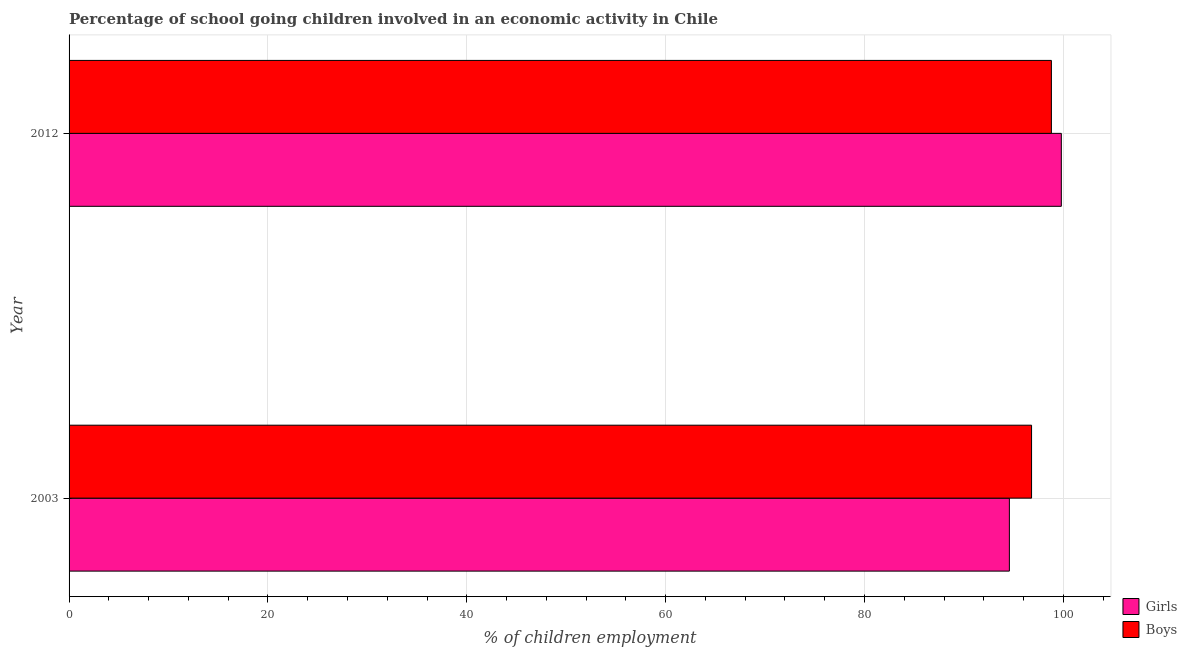Are the number of bars per tick equal to the number of legend labels?
Offer a very short reply. Yes. Are the number of bars on each tick of the Y-axis equal?
Provide a short and direct response. Yes. How many bars are there on the 2nd tick from the top?
Offer a terse response. 2. What is the percentage of school going boys in 2003?
Your response must be concise. 96.81. Across all years, what is the maximum percentage of school going girls?
Your response must be concise. 99.8. Across all years, what is the minimum percentage of school going girls?
Provide a short and direct response. 94.57. In which year was the percentage of school going girls maximum?
Your answer should be compact. 2012. In which year was the percentage of school going girls minimum?
Provide a short and direct response. 2003. What is the total percentage of school going boys in the graph?
Your answer should be compact. 195.61. What is the difference between the percentage of school going boys in 2003 and that in 2012?
Provide a short and direct response. -1.99. What is the difference between the percentage of school going boys in 2003 and the percentage of school going girls in 2012?
Make the answer very short. -2.99. What is the average percentage of school going girls per year?
Make the answer very short. 97.19. In the year 2003, what is the difference between the percentage of school going boys and percentage of school going girls?
Ensure brevity in your answer.  2.23. What is the ratio of the percentage of school going boys in 2003 to that in 2012?
Give a very brief answer. 0.98. What does the 2nd bar from the top in 2012 represents?
Provide a succinct answer. Girls. What does the 1st bar from the bottom in 2012 represents?
Your answer should be compact. Girls. Are all the bars in the graph horizontal?
Provide a succinct answer. Yes. How many years are there in the graph?
Ensure brevity in your answer.  2. Does the graph contain any zero values?
Your response must be concise. No. Does the graph contain grids?
Keep it short and to the point. Yes. Where does the legend appear in the graph?
Give a very brief answer. Bottom right. How are the legend labels stacked?
Keep it short and to the point. Vertical. What is the title of the graph?
Provide a succinct answer. Percentage of school going children involved in an economic activity in Chile. Does "Pregnant women" appear as one of the legend labels in the graph?
Your answer should be very brief. No. What is the label or title of the X-axis?
Give a very brief answer. % of children employment. What is the label or title of the Y-axis?
Your answer should be very brief. Year. What is the % of children employment of Girls in 2003?
Give a very brief answer. 94.57. What is the % of children employment of Boys in 2003?
Ensure brevity in your answer.  96.81. What is the % of children employment in Girls in 2012?
Ensure brevity in your answer.  99.8. What is the % of children employment of Boys in 2012?
Your answer should be compact. 98.8. Across all years, what is the maximum % of children employment of Girls?
Keep it short and to the point. 99.8. Across all years, what is the maximum % of children employment of Boys?
Your response must be concise. 98.8. Across all years, what is the minimum % of children employment of Girls?
Ensure brevity in your answer.  94.57. Across all years, what is the minimum % of children employment in Boys?
Give a very brief answer. 96.81. What is the total % of children employment in Girls in the graph?
Provide a succinct answer. 194.37. What is the total % of children employment in Boys in the graph?
Your response must be concise. 195.61. What is the difference between the % of children employment of Girls in 2003 and that in 2012?
Provide a short and direct response. -5.23. What is the difference between the % of children employment in Boys in 2003 and that in 2012?
Keep it short and to the point. -1.99. What is the difference between the % of children employment in Girls in 2003 and the % of children employment in Boys in 2012?
Your answer should be very brief. -4.23. What is the average % of children employment of Girls per year?
Ensure brevity in your answer.  97.19. What is the average % of children employment in Boys per year?
Make the answer very short. 97.8. In the year 2003, what is the difference between the % of children employment in Girls and % of children employment in Boys?
Give a very brief answer. -2.23. In the year 2012, what is the difference between the % of children employment in Girls and % of children employment in Boys?
Your response must be concise. 1. What is the ratio of the % of children employment in Girls in 2003 to that in 2012?
Your answer should be very brief. 0.95. What is the ratio of the % of children employment of Boys in 2003 to that in 2012?
Provide a succinct answer. 0.98. What is the difference between the highest and the second highest % of children employment in Girls?
Provide a short and direct response. 5.23. What is the difference between the highest and the second highest % of children employment of Boys?
Keep it short and to the point. 1.99. What is the difference between the highest and the lowest % of children employment in Girls?
Offer a terse response. 5.23. What is the difference between the highest and the lowest % of children employment in Boys?
Provide a succinct answer. 1.99. 